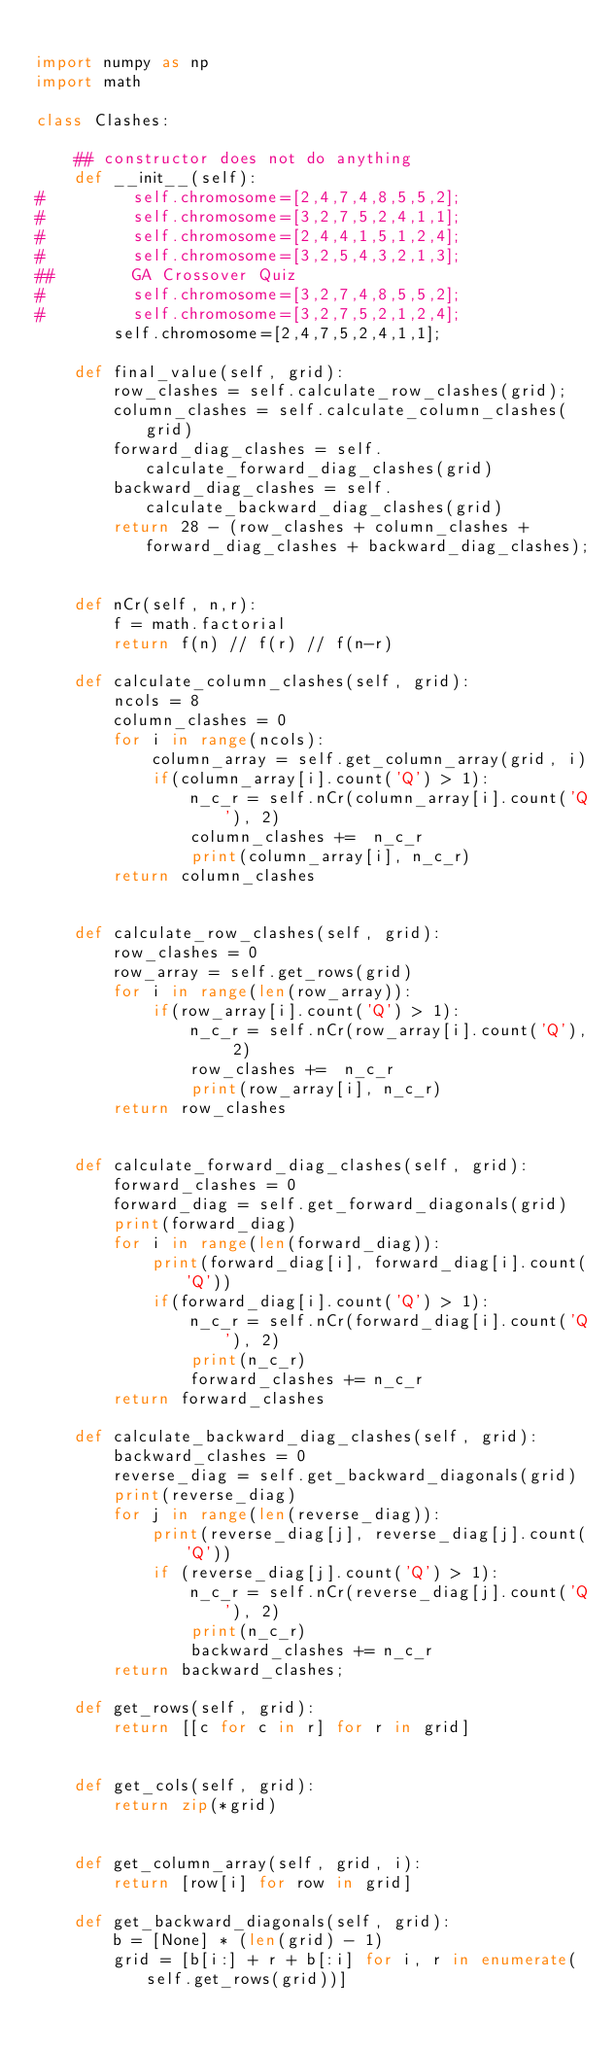<code> <loc_0><loc_0><loc_500><loc_500><_Python_>
import numpy as np
import math

class Clashes:
    
    ## constructor does not do anything
    def __init__(self):
#         self.chromosome=[2,4,7,4,8,5,5,2];
#         self.chromosome=[3,2,7,5,2,4,1,1];
#         self.chromosome=[2,4,4,1,5,1,2,4];
#         self.chromosome=[3,2,5,4,3,2,1,3];
##        GA Crossover Quiz
#         self.chromosome=[3,2,7,4,8,5,5,2];
#         self.chromosome=[3,2,7,5,2,1,2,4];        
        self.chromosome=[2,4,7,5,2,4,1,1];                

    def final_value(self, grid):        
        row_clashes = self.calculate_row_clashes(grid);
        column_clashes = self.calculate_column_clashes(grid)
        forward_diag_clashes = self.calculate_forward_diag_clashes(grid)
        backward_diag_clashes = self.calculate_backward_diag_clashes(grid)
        return 28 - (row_clashes + column_clashes + forward_diag_clashes + backward_diag_clashes);


    def nCr(self, n,r):
        f = math.factorial
        return f(n) // f(r) // f(n-r)

    def calculate_column_clashes(self, grid):
        ncols = 8
        column_clashes = 0
        for i in range(ncols):
            column_array = self.get_column_array(grid, i)
            if(column_array[i].count('Q') > 1):
                n_c_r = self.nCr(column_array[i].count('Q'), 2)
                column_clashes +=  n_c_r
                print(column_array[i], n_c_r)                        
        return column_clashes


    def calculate_row_clashes(self, grid):
        row_clashes = 0
        row_array = self.get_rows(grid)
        for i in range(len(row_array)):
            if(row_array[i].count('Q') > 1):
                n_c_r = self.nCr(row_array[i].count('Q'), 2)
                row_clashes +=  n_c_r
                print(row_array[i], n_c_r)
        return row_clashes


    def calculate_forward_diag_clashes(self, grid):
        forward_clashes = 0
        forward_diag = self.get_forward_diagonals(grid)
        print(forward_diag)
        for i in range(len(forward_diag)):
            print(forward_diag[i], forward_diag[i].count('Q'))
            if(forward_diag[i].count('Q') > 1):
                n_c_r = self.nCr(forward_diag[i].count('Q'), 2)
                print(n_c_r)
                forward_clashes += n_c_r
        return forward_clashes

    def calculate_backward_diag_clashes(self, grid):
        backward_clashes = 0
        reverse_diag = self.get_backward_diagonals(grid)        
        print(reverse_diag)
        for j in range(len(reverse_diag)):
            print(reverse_diag[j], reverse_diag[j].count('Q'))
            if (reverse_diag[j].count('Q') > 1):
                n_c_r = self.nCr(reverse_diag[j].count('Q'), 2)
                print(n_c_r)
                backward_clashes += n_c_r
        return backward_clashes;

    def get_rows(self, grid):
        return [[c for c in r] for r in grid]


    def get_cols(self, grid):
        return zip(*grid)


    def get_column_array(self, grid, i):
        return [row[i] for row in grid]

    def get_backward_diagonals(self, grid):
        b = [None] * (len(grid) - 1)
        grid = [b[i:] + r + b[:i] for i, r in enumerate(self.get_rows(grid))]</code> 